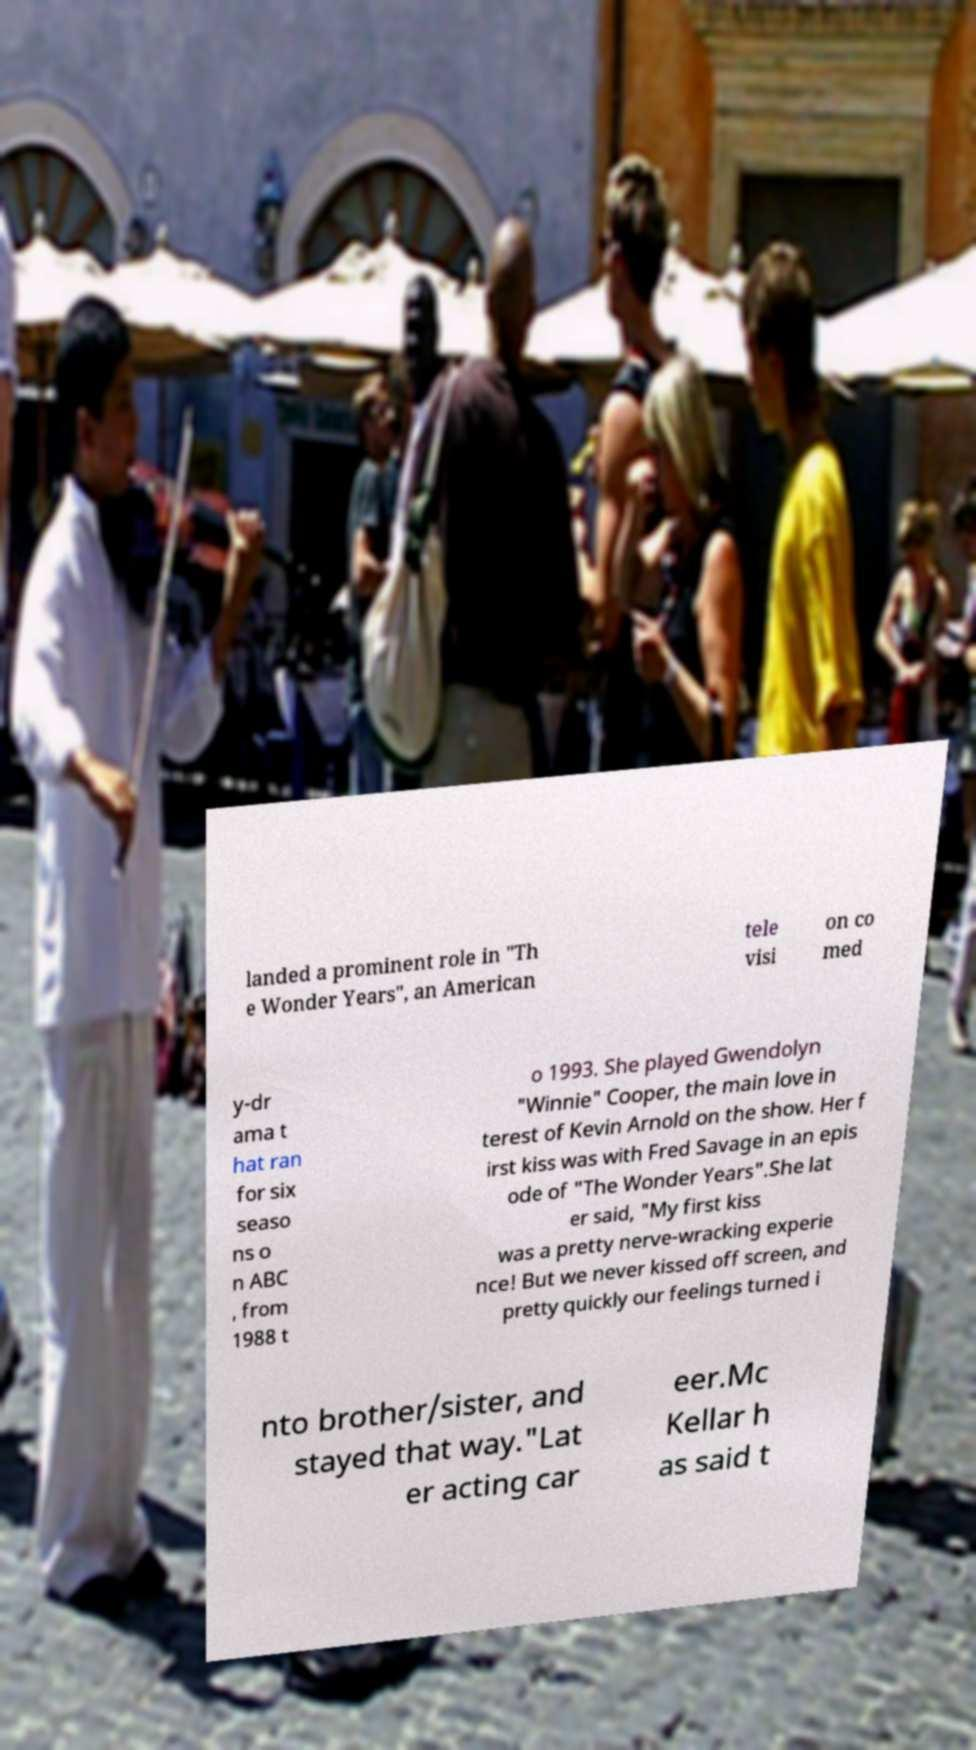Could you assist in decoding the text presented in this image and type it out clearly? landed a prominent role in "Th e Wonder Years", an American tele visi on co med y-dr ama t hat ran for six seaso ns o n ABC , from 1988 t o 1993. She played Gwendolyn "Winnie" Cooper, the main love in terest of Kevin Arnold on the show. Her f irst kiss was with Fred Savage in an epis ode of "The Wonder Years".She lat er said, "My first kiss was a pretty nerve-wracking experie nce! But we never kissed off screen, and pretty quickly our feelings turned i nto brother/sister, and stayed that way."Lat er acting car eer.Mc Kellar h as said t 